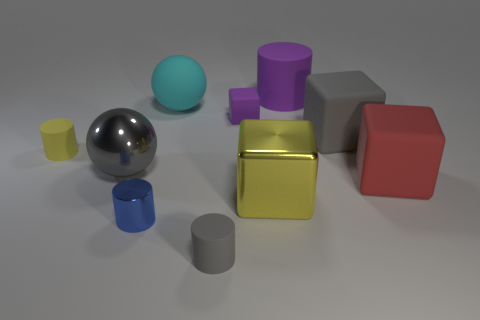Is there anything else that is made of the same material as the yellow cube?
Offer a terse response. Yes. Is the shape of the gray rubber object that is in front of the tiny blue cylinder the same as the big object that is to the left of the blue cylinder?
Offer a very short reply. No. Are there fewer tiny purple cubes that are to the left of the small blue object than big green objects?
Your answer should be compact. No. How many other metal cubes have the same color as the metallic cube?
Your answer should be compact. 0. There is a ball behind the gray sphere; what size is it?
Your response must be concise. Large. What is the shape of the metallic thing that is behind the thing right of the big rubber cube behind the tiny yellow rubber object?
Provide a succinct answer. Sphere. There is a big object that is left of the large metal block and behind the gray matte cube; what is its shape?
Make the answer very short. Sphere. Are there any other yellow rubber cylinders of the same size as the yellow rubber cylinder?
Make the answer very short. No. There is a gray rubber thing that is in front of the large red cube; is its shape the same as the large cyan rubber thing?
Offer a terse response. No. Do the cyan rubber object and the yellow matte thing have the same shape?
Ensure brevity in your answer.  No. 